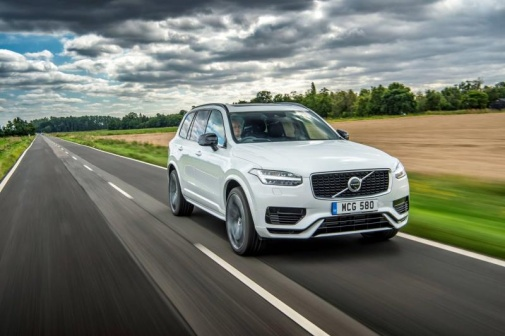What do you see happening in this image? The image captures the serene moment of a white Volvo XC90 SUV driving along a two-lane highway. Positioned in the right lane and moving towards the right side of the frame, the SUV's license plate reads 'MC6 580.' The scene is set against a lush backdrop, with green fields and trees flanking the road, under a cloudy sky that gives off a soft light. The wet road surface suggests recent rainfall, adding a refreshing touch to the peaceful rural landscape, making it a picturesque representation of a tranquil drive through nature. 